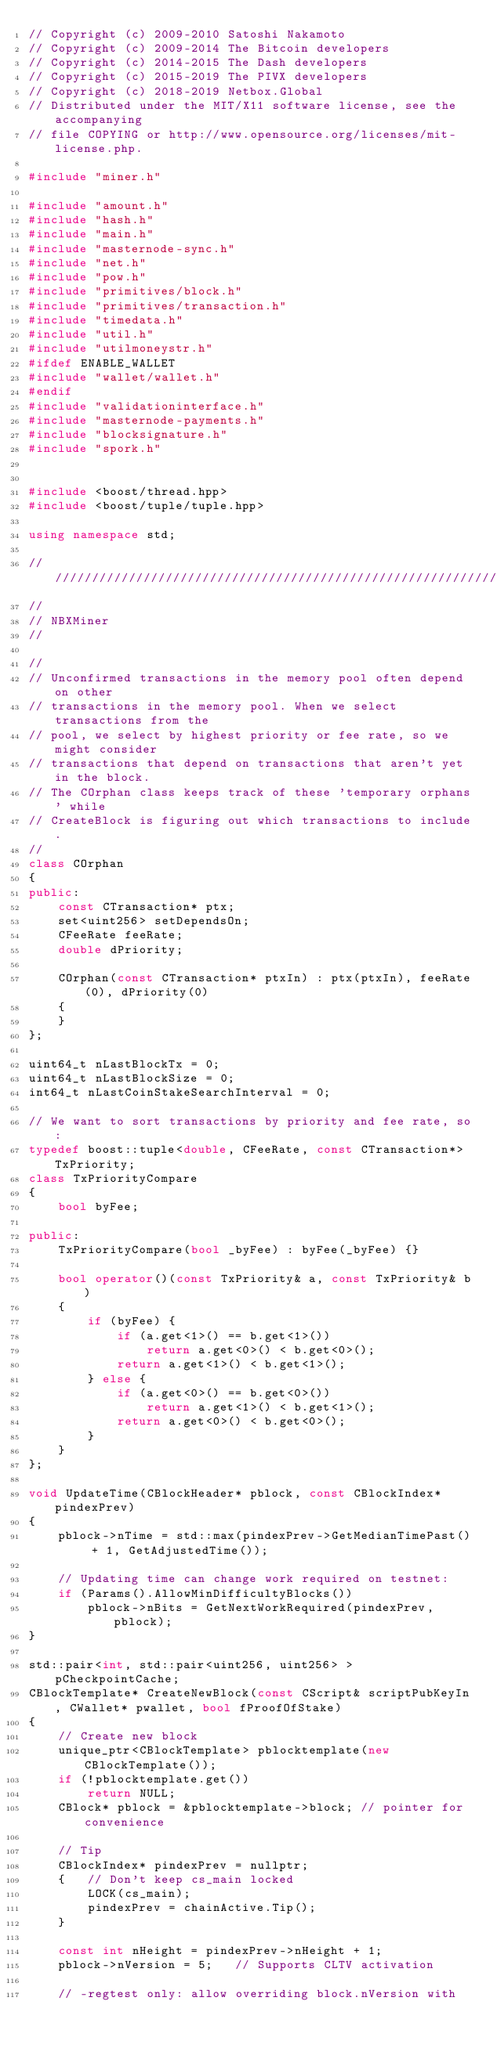Convert code to text. <code><loc_0><loc_0><loc_500><loc_500><_C++_>// Copyright (c) 2009-2010 Satoshi Nakamoto
// Copyright (c) 2009-2014 The Bitcoin developers
// Copyright (c) 2014-2015 The Dash developers
// Copyright (c) 2015-2019 The PIVX developers
// Copyright (c) 2018-2019 Netbox.Global
// Distributed under the MIT/X11 software license, see the accompanying
// file COPYING or http://www.opensource.org/licenses/mit-license.php.

#include "miner.h"

#include "amount.h"
#include "hash.h"
#include "main.h"
#include "masternode-sync.h"
#include "net.h"
#include "pow.h"
#include "primitives/block.h"
#include "primitives/transaction.h"
#include "timedata.h"
#include "util.h"
#include "utilmoneystr.h"
#ifdef ENABLE_WALLET
#include "wallet/wallet.h"
#endif
#include "validationinterface.h"
#include "masternode-payments.h"
#include "blocksignature.h"
#include "spork.h"


#include <boost/thread.hpp>
#include <boost/tuple/tuple.hpp>

using namespace std;

//////////////////////////////////////////////////////////////////////////////
//
// NBXMiner
//

//
// Unconfirmed transactions in the memory pool often depend on other
// transactions in the memory pool. When we select transactions from the
// pool, we select by highest priority or fee rate, so we might consider
// transactions that depend on transactions that aren't yet in the block.
// The COrphan class keeps track of these 'temporary orphans' while
// CreateBlock is figuring out which transactions to include.
//
class COrphan
{
public:
    const CTransaction* ptx;
    set<uint256> setDependsOn;
    CFeeRate feeRate;
    double dPriority;

    COrphan(const CTransaction* ptxIn) : ptx(ptxIn), feeRate(0), dPriority(0)
    {
    }
};

uint64_t nLastBlockTx = 0;
uint64_t nLastBlockSize = 0;
int64_t nLastCoinStakeSearchInterval = 0;

// We want to sort transactions by priority and fee rate, so:
typedef boost::tuple<double, CFeeRate, const CTransaction*> TxPriority;
class TxPriorityCompare
{
    bool byFee;

public:
    TxPriorityCompare(bool _byFee) : byFee(_byFee) {}

    bool operator()(const TxPriority& a, const TxPriority& b)
    {
        if (byFee) {
            if (a.get<1>() == b.get<1>())
                return a.get<0>() < b.get<0>();
            return a.get<1>() < b.get<1>();
        } else {
            if (a.get<0>() == b.get<0>())
                return a.get<1>() < b.get<1>();
            return a.get<0>() < b.get<0>();
        }
    }
};

void UpdateTime(CBlockHeader* pblock, const CBlockIndex* pindexPrev)
{
    pblock->nTime = std::max(pindexPrev->GetMedianTimePast() + 1, GetAdjustedTime());

    // Updating time can change work required on testnet:
    if (Params().AllowMinDifficultyBlocks())
        pblock->nBits = GetNextWorkRequired(pindexPrev, pblock);
}

std::pair<int, std::pair<uint256, uint256> > pCheckpointCache;
CBlockTemplate* CreateNewBlock(const CScript& scriptPubKeyIn, CWallet* pwallet, bool fProofOfStake)
{
    // Create new block
    unique_ptr<CBlockTemplate> pblocktemplate(new CBlockTemplate());
    if (!pblocktemplate.get())
        return NULL;
    CBlock* pblock = &pblocktemplate->block; // pointer for convenience

    // Tip
    CBlockIndex* pindexPrev = nullptr;
    {   // Don't keep cs_main locked
        LOCK(cs_main);
        pindexPrev = chainActive.Tip();
    }

    const int nHeight = pindexPrev->nHeight + 1;
    pblock->nVersion = 5;   // Supports CLTV activation

    // -regtest only: allow overriding block.nVersion with</code> 